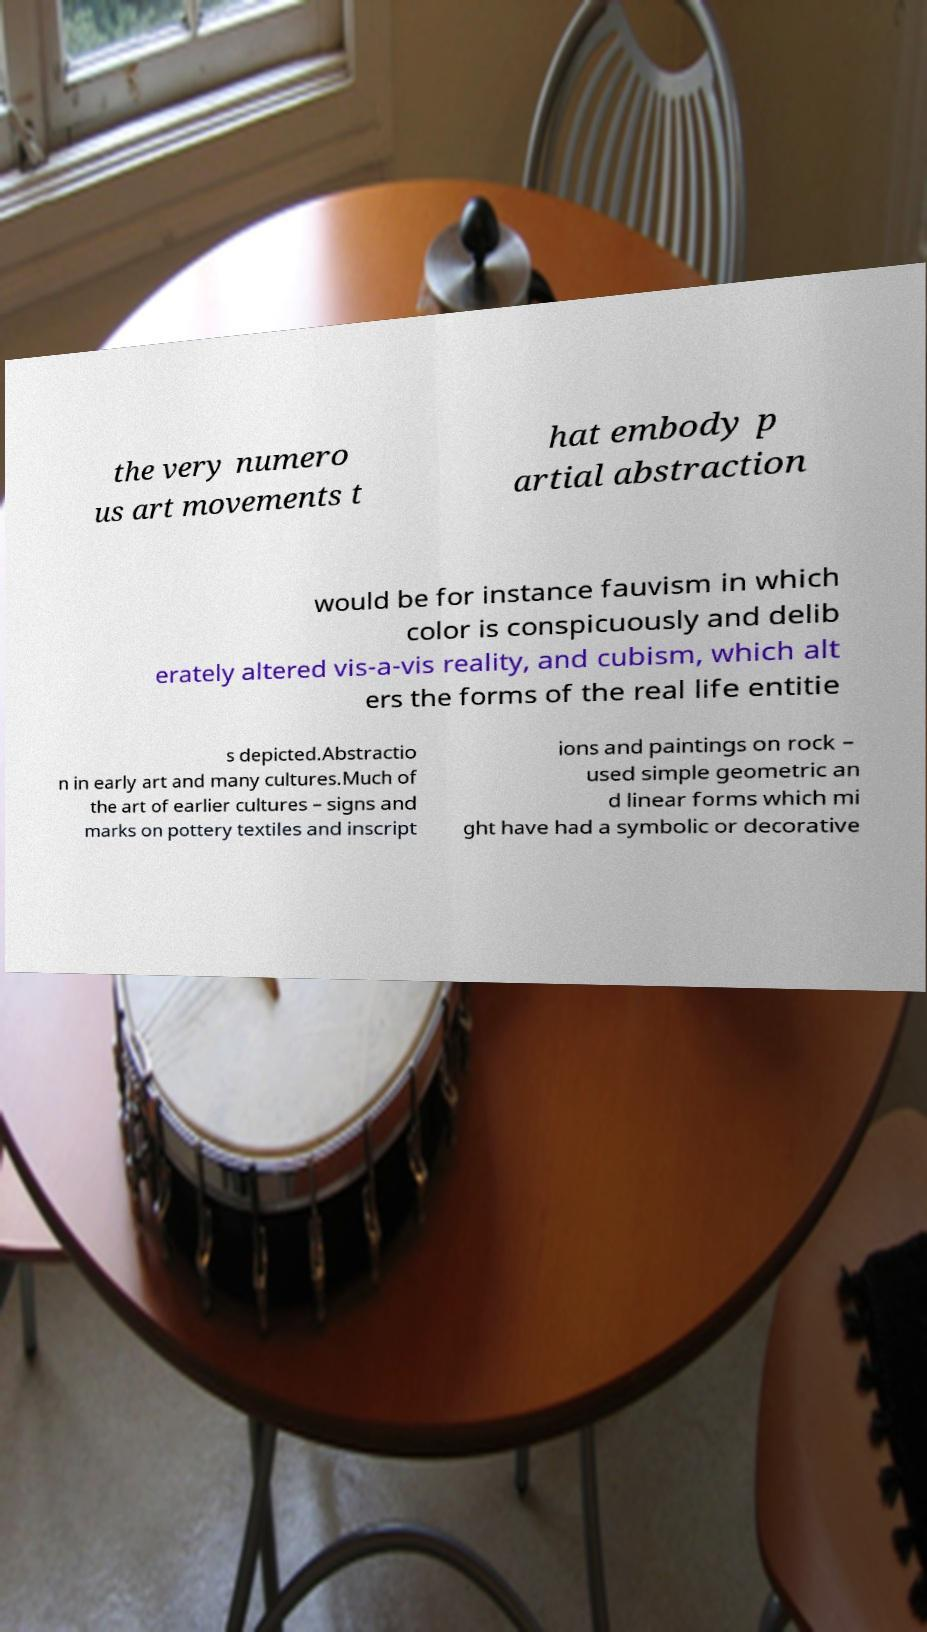Can you read and provide the text displayed in the image?This photo seems to have some interesting text. Can you extract and type it out for me? the very numero us art movements t hat embody p artial abstraction would be for instance fauvism in which color is conspicuously and delib erately altered vis-a-vis reality, and cubism, which alt ers the forms of the real life entitie s depicted.Abstractio n in early art and many cultures.Much of the art of earlier cultures – signs and marks on pottery textiles and inscript ions and paintings on rock – used simple geometric an d linear forms which mi ght have had a symbolic or decorative 